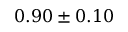<formula> <loc_0><loc_0><loc_500><loc_500>0 . 9 0 \pm 0 . 1 0</formula> 